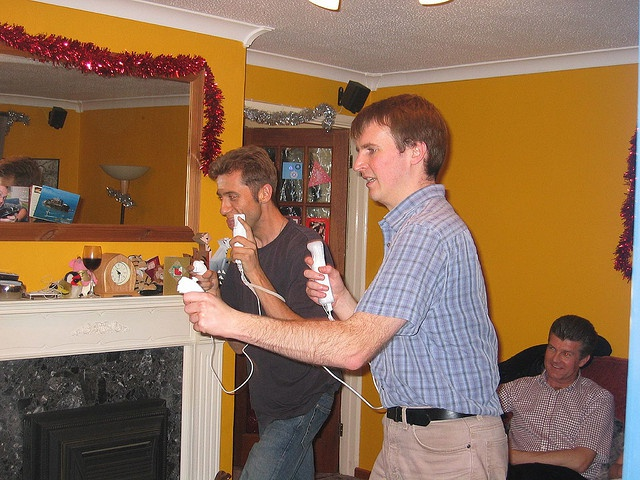Describe the objects in this image and their specific colors. I can see people in orange, darkgray, lightpink, and maroon tones, people in orange, black, gray, maroon, and brown tones, people in orange, gray, black, and darkgray tones, couch in orange, black, maroon, and gray tones, and chair in orange, maroon, black, lightblue, and gray tones in this image. 